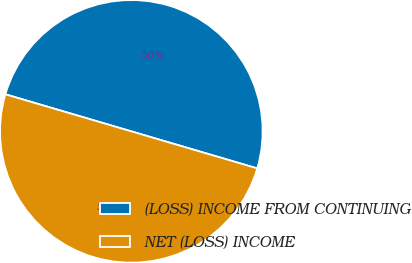Convert chart to OTSL. <chart><loc_0><loc_0><loc_500><loc_500><pie_chart><fcel>(LOSS) INCOME FROM CONTINUING<fcel>NET (LOSS) INCOME<nl><fcel>50.0%<fcel>50.0%<nl></chart> 